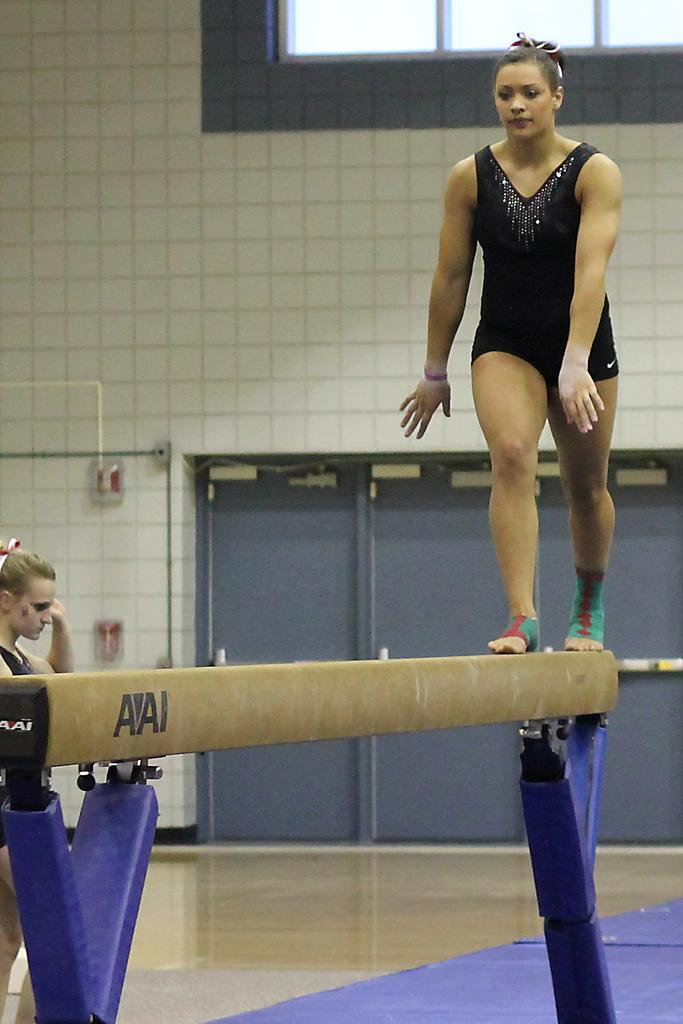What is the main object in the image? There is a balance beam in the image. Who is present in the image? There are two women in the image. What is at the bottom of the image? There is a mat at the bottom of the image. What can be seen in the background of the image? There are doors, windows, a pipe, and other objects in the background of the image. Where is the sofa located in the image? There is no sofa present in the image. What type of drain is visible in the image? There is no drain visible in the image. 